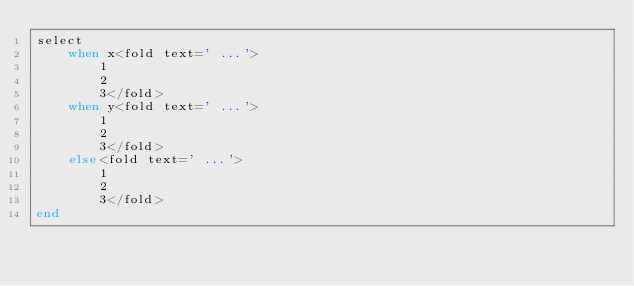Convert code to text. <code><loc_0><loc_0><loc_500><loc_500><_Crystal_>select
    when x<fold text=' ...'>
        1
        2
        3</fold>
    when y<fold text=' ...'>
        1
        2
        3</fold>
    else<fold text=' ...'>
        1
        2
        3</fold>
end</code> 